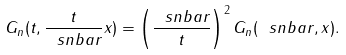Convert formula to latex. <formula><loc_0><loc_0><loc_500><loc_500>G _ { n } ( t , \frac { t } { \ s n b a r } x ) = \left ( \frac { \ s n b a r } { t } \right ) ^ { 2 } G _ { n } ( \ s n b a r , x ) .</formula> 